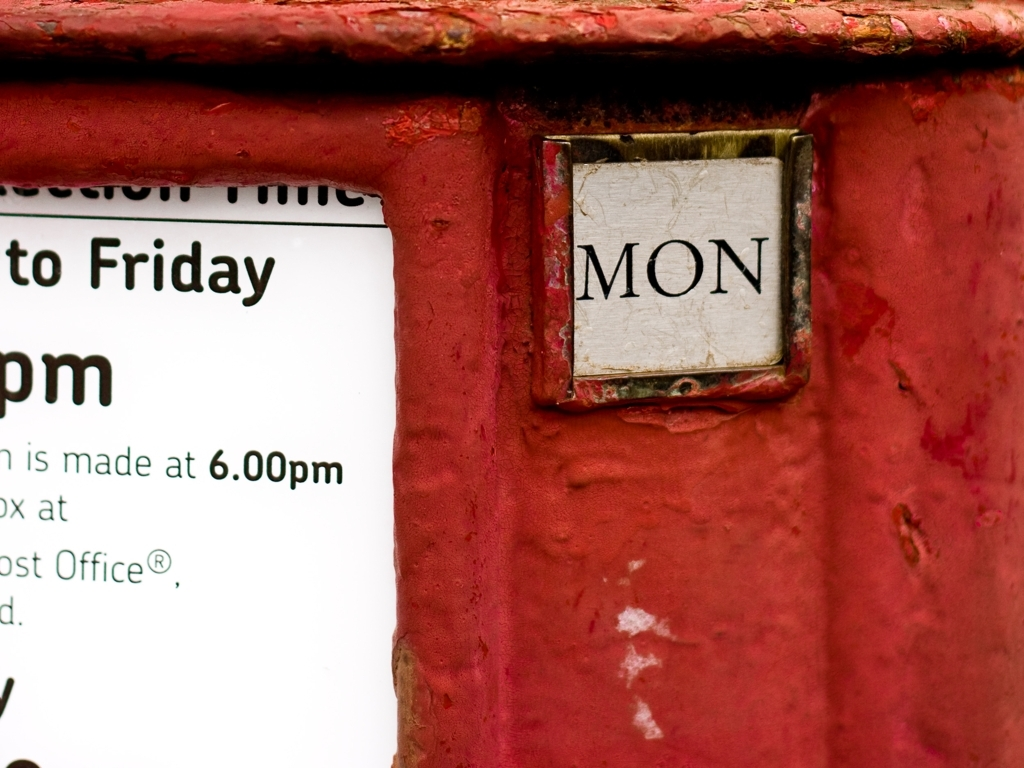Why might the red surface surrounding the sign be important? The red surface is a hallmark color often associated with British Royal Mail post boxes. This vibrant color aids visibility, ensuring it is easily noticed by passersby who may need to post mail. 